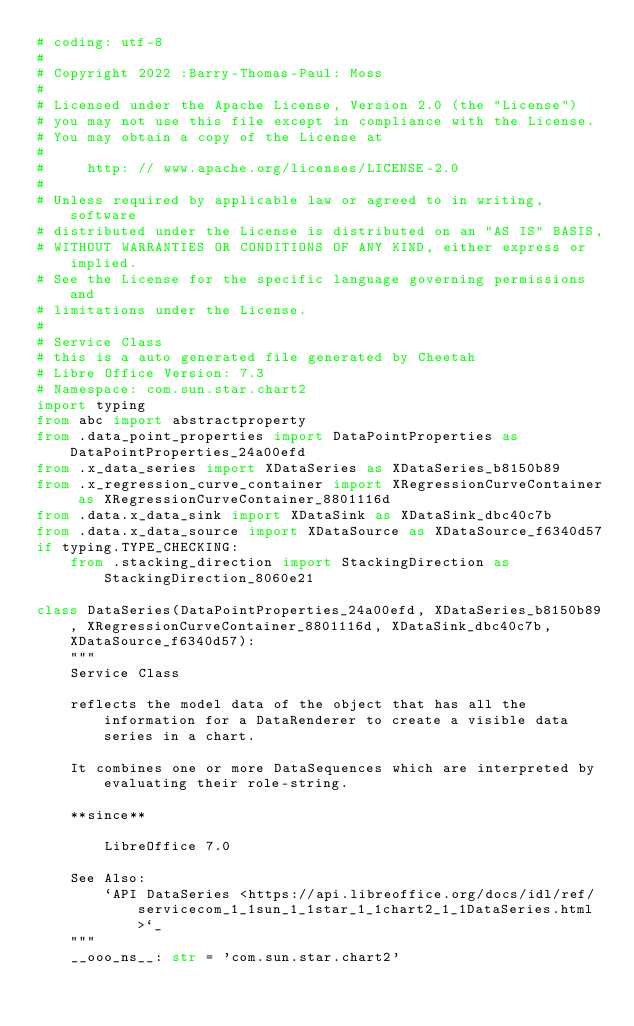<code> <loc_0><loc_0><loc_500><loc_500><_Python_># coding: utf-8
#
# Copyright 2022 :Barry-Thomas-Paul: Moss
#
# Licensed under the Apache License, Version 2.0 (the "License")
# you may not use this file except in compliance with the License.
# You may obtain a copy of the License at
#
#     http: // www.apache.org/licenses/LICENSE-2.0
#
# Unless required by applicable law or agreed to in writing, software
# distributed under the License is distributed on an "AS IS" BASIS,
# WITHOUT WARRANTIES OR CONDITIONS OF ANY KIND, either express or implied.
# See the License for the specific language governing permissions and
# limitations under the License.
#
# Service Class
# this is a auto generated file generated by Cheetah
# Libre Office Version: 7.3
# Namespace: com.sun.star.chart2
import typing
from abc import abstractproperty
from .data_point_properties import DataPointProperties as DataPointProperties_24a00efd
from .x_data_series import XDataSeries as XDataSeries_b8150b89
from .x_regression_curve_container import XRegressionCurveContainer as XRegressionCurveContainer_8801116d
from .data.x_data_sink import XDataSink as XDataSink_dbc40c7b
from .data.x_data_source import XDataSource as XDataSource_f6340d57
if typing.TYPE_CHECKING:
    from .stacking_direction import StackingDirection as StackingDirection_8060e21

class DataSeries(DataPointProperties_24a00efd, XDataSeries_b8150b89, XRegressionCurveContainer_8801116d, XDataSink_dbc40c7b, XDataSource_f6340d57):
    """
    Service Class

    reflects the model data of the object that has all the information for a DataRenderer to create a visible data series in a chart.
    
    It combines one or more DataSequences which are interpreted by evaluating their role-string.
    
    **since**
    
        LibreOffice 7.0

    See Also:
        `API DataSeries <https://api.libreoffice.org/docs/idl/ref/servicecom_1_1sun_1_1star_1_1chart2_1_1DataSeries.html>`_
    """
    __ooo_ns__: str = 'com.sun.star.chart2'</code> 